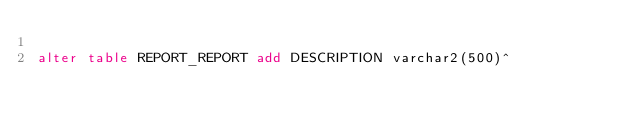<code> <loc_0><loc_0><loc_500><loc_500><_SQL_>
alter table REPORT_REPORT add DESCRIPTION varchar2(500)^</code> 